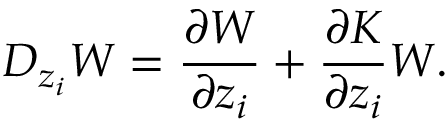<formula> <loc_0><loc_0><loc_500><loc_500>D _ { z _ { i } } W = \frac { \partial W } { \partial z _ { i } } + \frac { \partial K } { \partial z _ { i } } W .</formula> 